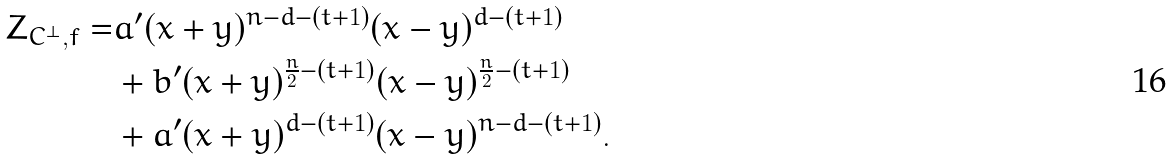<formula> <loc_0><loc_0><loc_500><loc_500>Z _ { C ^ { \perp } , f } = & a ^ { \prime } ( x + y ) ^ { n - d - ( t + 1 ) } ( x - y ) ^ { d - ( t + 1 ) } \\ & + b ^ { \prime } ( x + y ) ^ { \frac { n } { 2 } - ( t + 1 ) } ( x - y ) ^ { \frac { n } { 2 } - ( t + 1 ) } \\ & + a ^ { \prime } ( x + y ) ^ { d - ( t + 1 ) } ( x - y ) ^ { n - d - ( t + 1 ) } .</formula> 